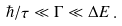Convert formula to latex. <formula><loc_0><loc_0><loc_500><loc_500>\hbar { / } \tau \ll \Gamma \ll \Delta E \, .</formula> 